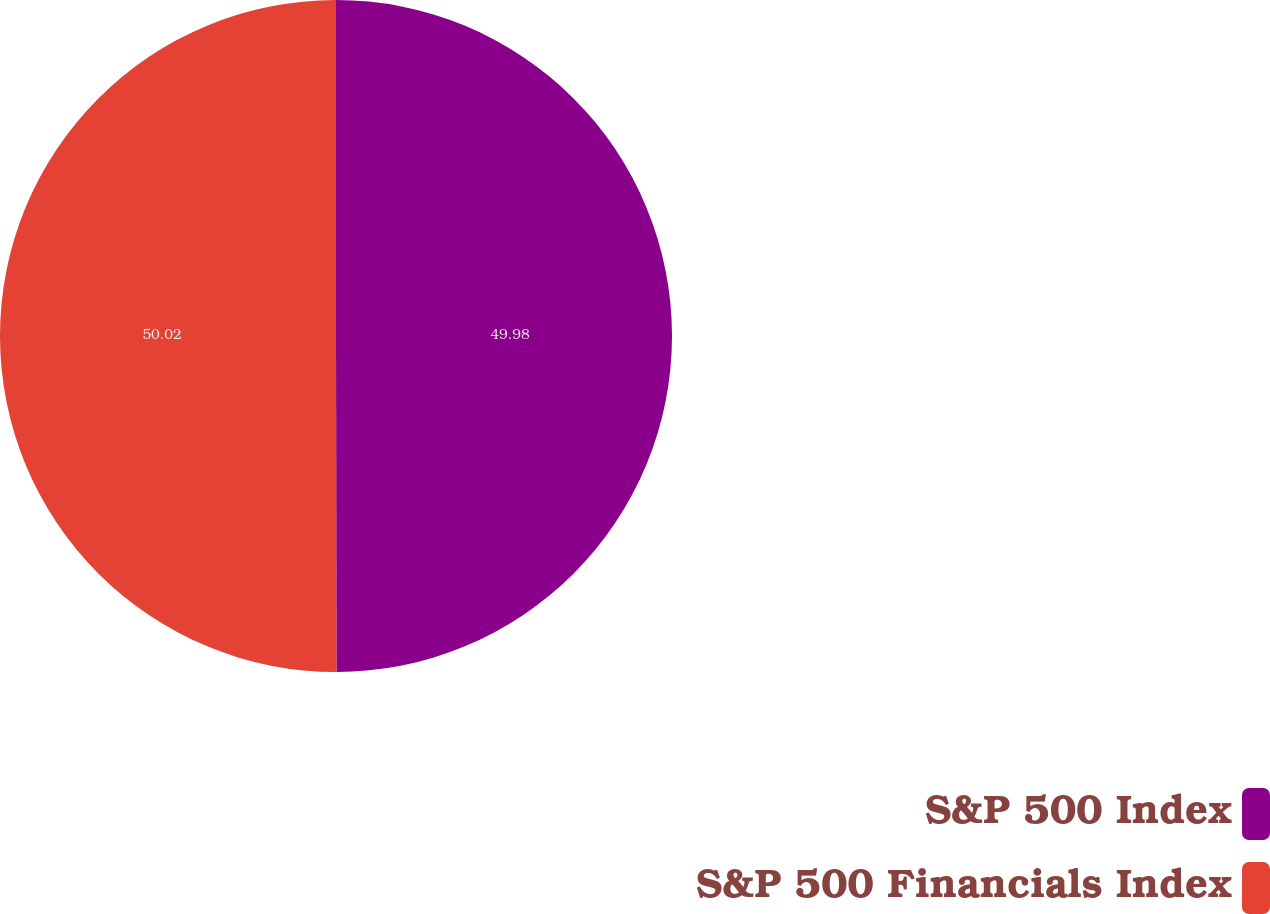<chart> <loc_0><loc_0><loc_500><loc_500><pie_chart><fcel>S&P 500 Index<fcel>S&P 500 Financials Index<nl><fcel>49.98%<fcel>50.02%<nl></chart> 